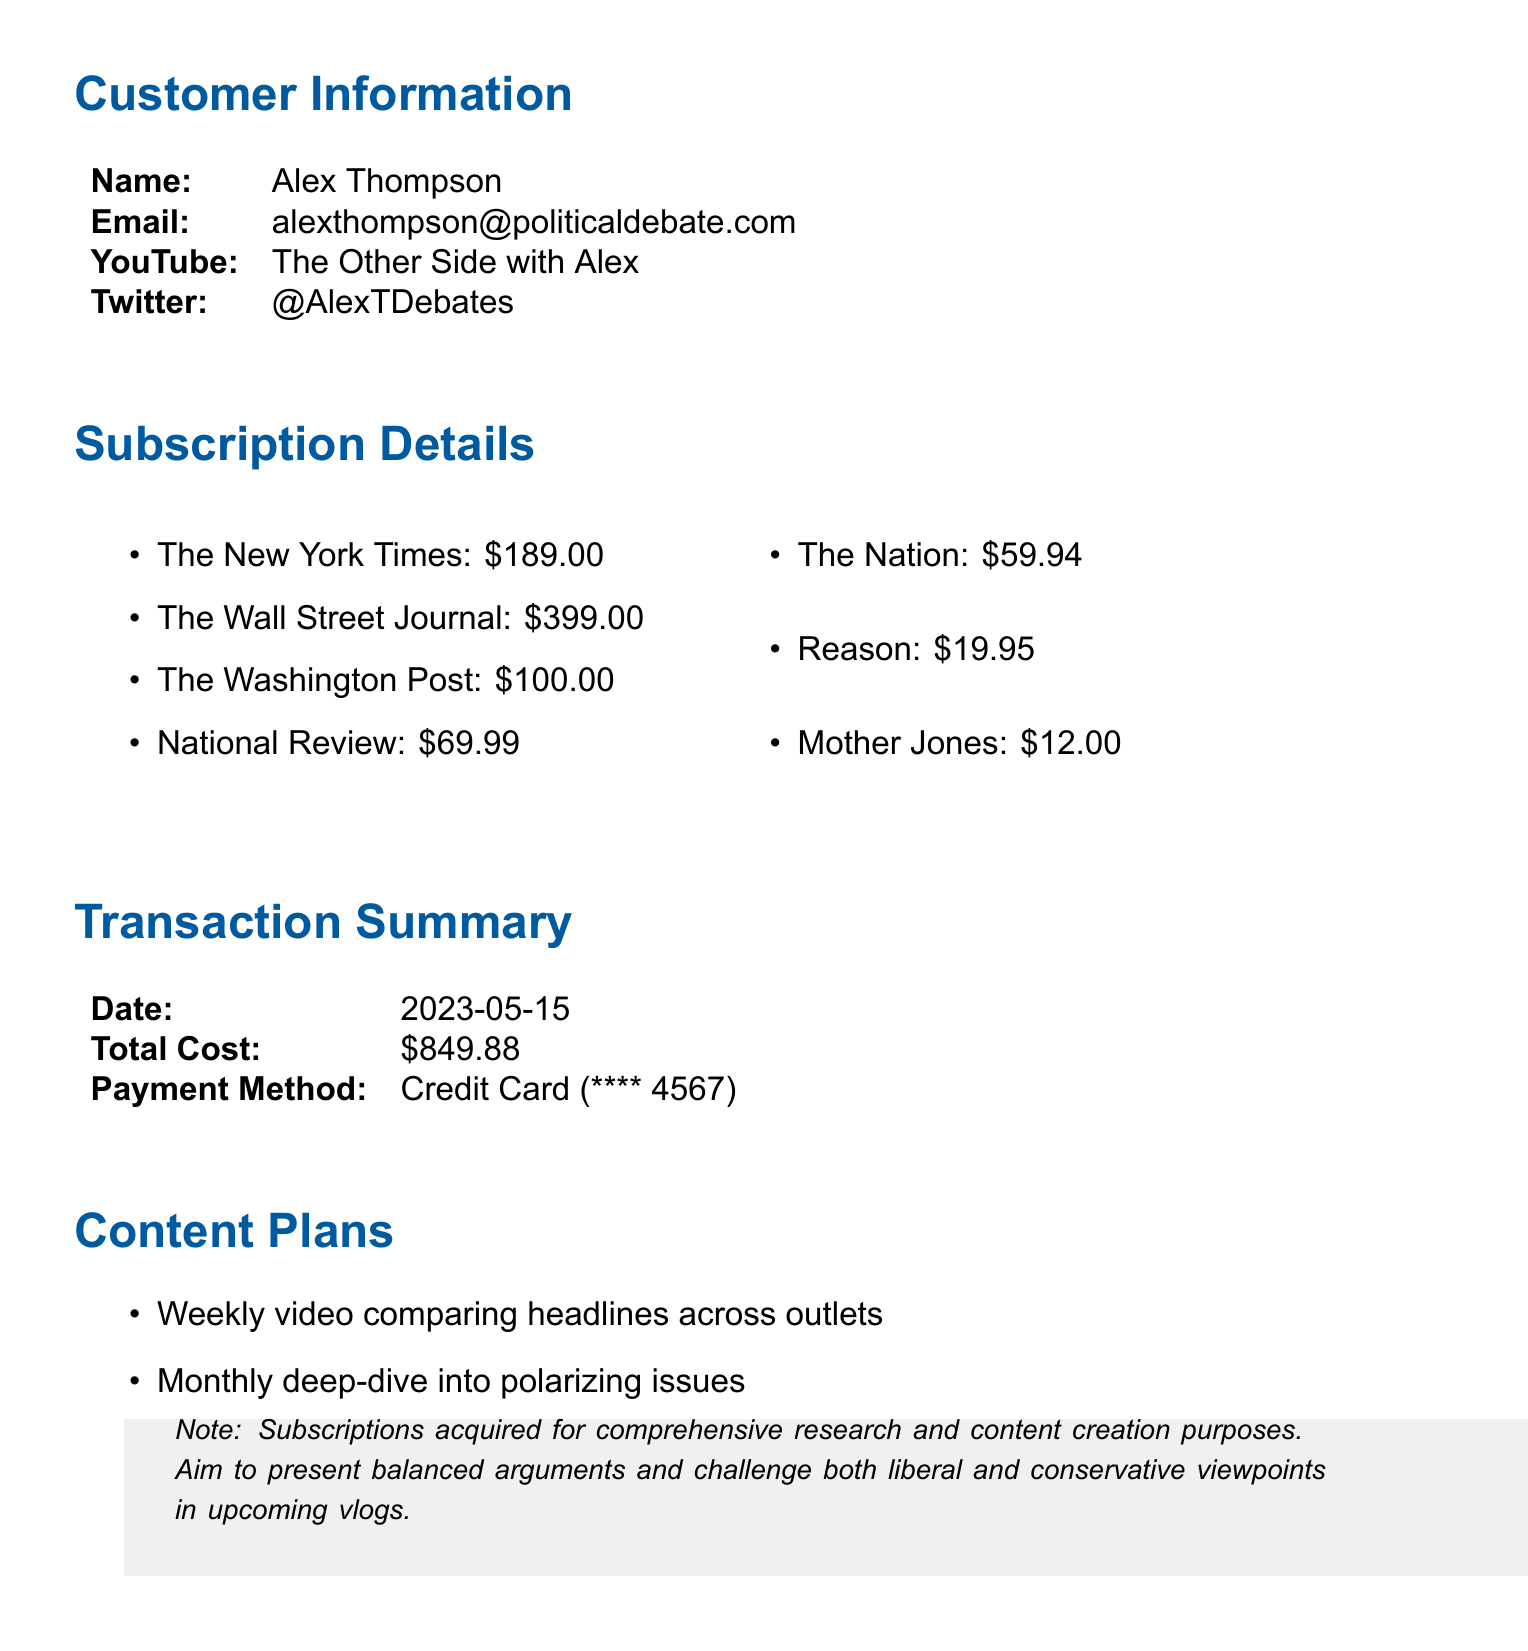What is the name of the customer? The document contains the customer's name listed in the customer information section, which is Alex Thompson.
Answer: Alex Thompson What is the total cost of the subscriptions? The total cost is stated in the transaction summary section of the document, which adds up all subscription costs.
Answer: $849.88 Which payment method was used? The payment method is detailed in the transaction summary section, specifying the type of payment and the last four digits of the card used.
Answer: Credit Card What outlet has the highest subscription cost? The subscription costs for each outlet are listed, with The Wall Street Journal having the highest price.
Answer: The Wall Street Journal What was the transaction date? The date of the transaction is mentioned in the transaction summary section.
Answer: 2023-05-15 What is the duration of the subscriptions? All subscriptions are for a fixed period, which is stated in the document for each outlet.
Answer: 1 year What type of content plans are listed? The document includes specific plans for content creation based on the subscriptions acquired, which are detailed in the content plans section.
Answer: Comparing headlines, deep-dive into issues, fact-check roundup What is the referral source for the subscriptions? The document indicates the referral source at the bottom, which is where the customer learned about the subscriptions.
Answer: Political Compass Podcast recommendation How many different news outlets are subscribed to? The subscriptions section lists the outlets included in this transaction, allowing us to count each unique entry.
Answer: 7 